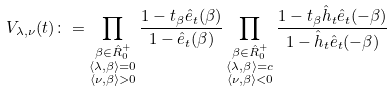Convert formula to latex. <formula><loc_0><loc_0><loc_500><loc_500>V _ { \lambda , \nu } ( t ) & \colon = \prod _ { \substack { \beta \in { \hat { R } _ { 0 } ^ { + } } \\ \langle \lambda , \beta \rangle = 0 \\ \langle \nu , \beta \rangle > 0 } } \frac { 1 - t _ { \beta } \hat { e } _ { t } ( \beta ) } { 1 - \hat { e } _ { t } ( \beta ) } \prod _ { \substack { \beta \in { \hat { R } _ { 0 } ^ { + } } \\ \langle \lambda , \beta \rangle = c \\ \langle \nu , \beta \rangle < 0 } } \frac { 1 - t _ { \beta } \hat { h } _ { t } \hat { e } _ { t } ( - \beta ) } { 1 - \hat { h } _ { t } \hat { e } _ { t } ( - \beta ) }</formula> 